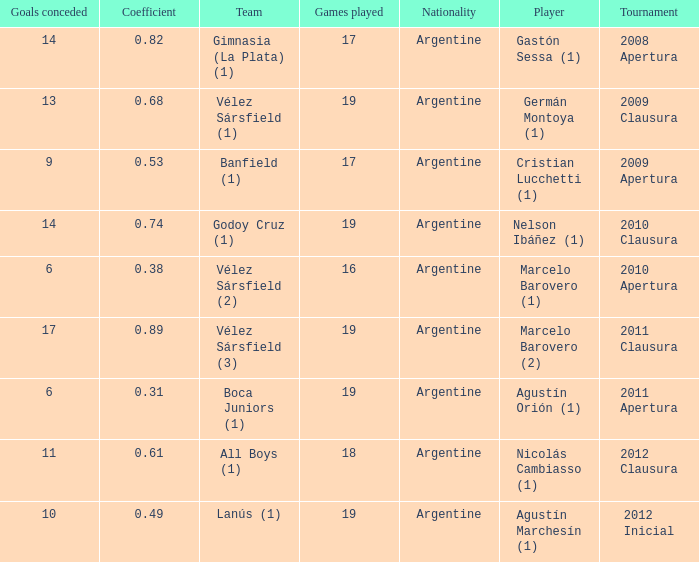What is the coefficient for agustín marchesín (1)? 0.49. 